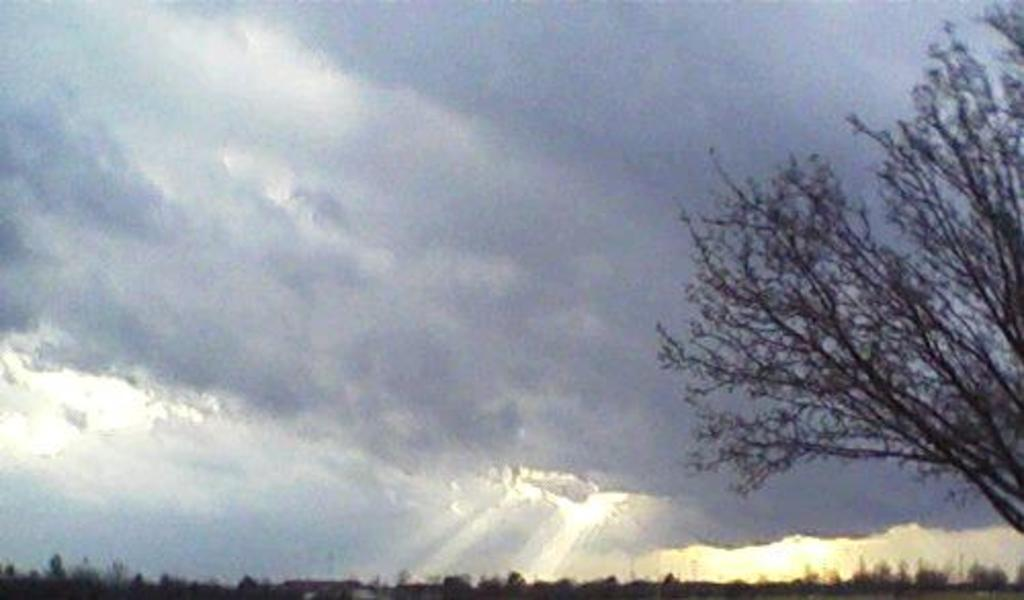What type of vegetation can be seen in the image? There are trees in the image. What is visible in the background of the image? The sky is visible in the background of the image. Can you describe the sky in the image? The sky appears to be cloudy in the image. What type of calculator can be seen hanging from the tree in the image? There is no calculator present in the image, and trees are not capable of hanging objects. 